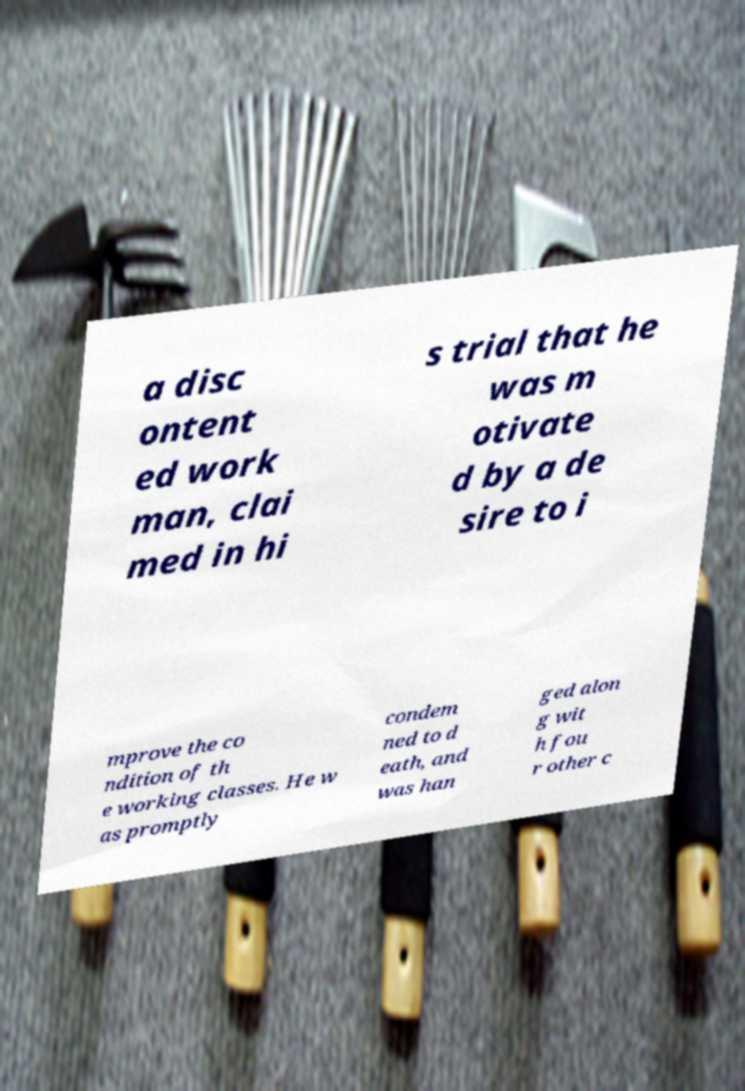For documentation purposes, I need the text within this image transcribed. Could you provide that? a disc ontent ed work man, clai med in hi s trial that he was m otivate d by a de sire to i mprove the co ndition of th e working classes. He w as promptly condem ned to d eath, and was han ged alon g wit h fou r other c 